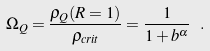<formula> <loc_0><loc_0><loc_500><loc_500>\Omega _ { Q } = \frac { \rho _ { Q } ( R = 1 ) } { \rho _ { c r i t } } = \frac { 1 } { 1 + b ^ { \alpha } } \ .</formula> 